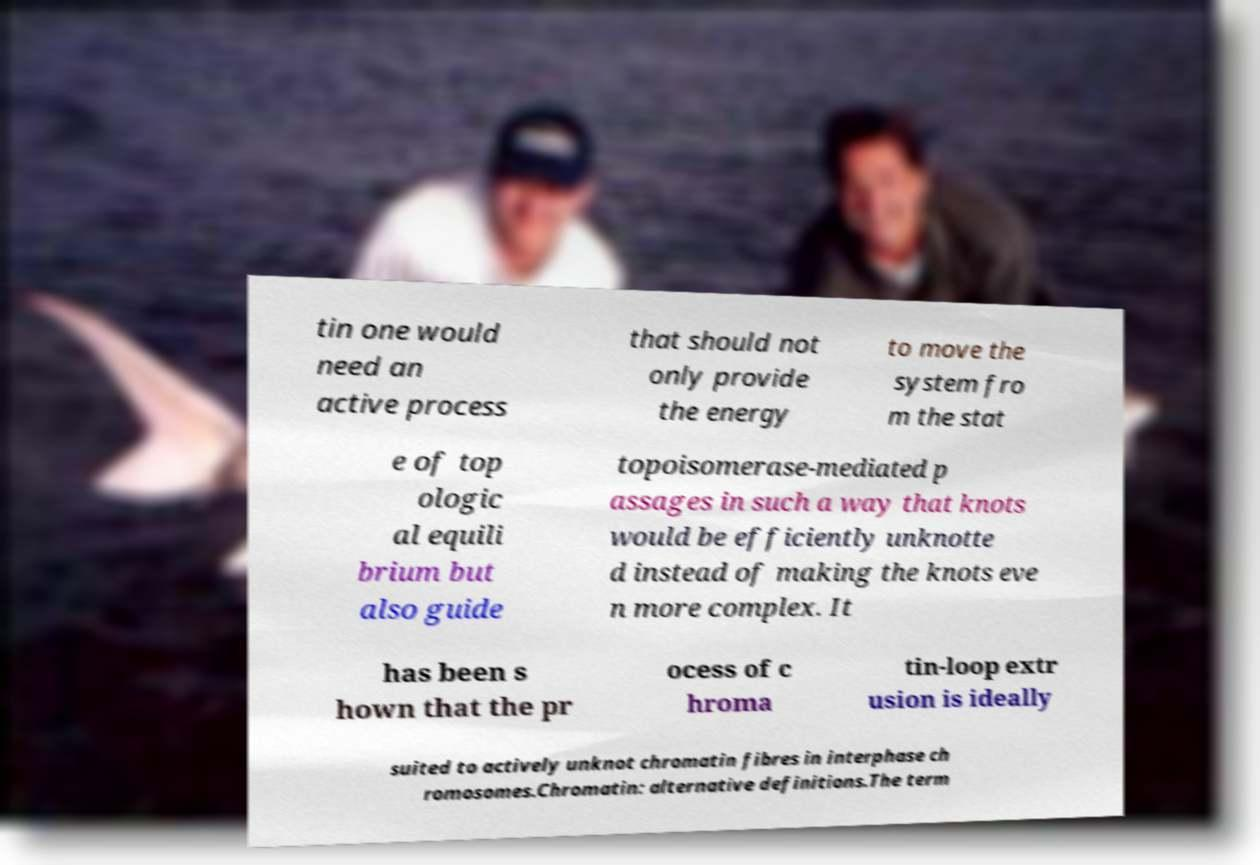Can you read and provide the text displayed in the image?This photo seems to have some interesting text. Can you extract and type it out for me? tin one would need an active process that should not only provide the energy to move the system fro m the stat e of top ologic al equili brium but also guide topoisomerase-mediated p assages in such a way that knots would be efficiently unknotte d instead of making the knots eve n more complex. It has been s hown that the pr ocess of c hroma tin-loop extr usion is ideally suited to actively unknot chromatin fibres in interphase ch romosomes.Chromatin: alternative definitions.The term 